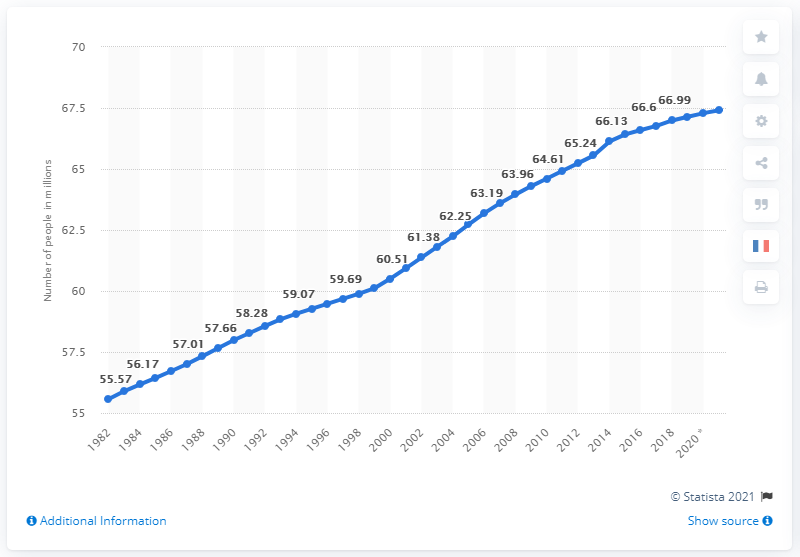Give some essential details in this illustration. As of 2021, the population of France is estimated to be 67.41 million people. 